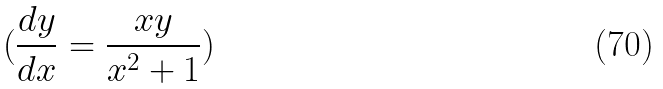Convert formula to latex. <formula><loc_0><loc_0><loc_500><loc_500>( \frac { d y } { d x } = \frac { x y } { x ^ { 2 } + 1 } )</formula> 